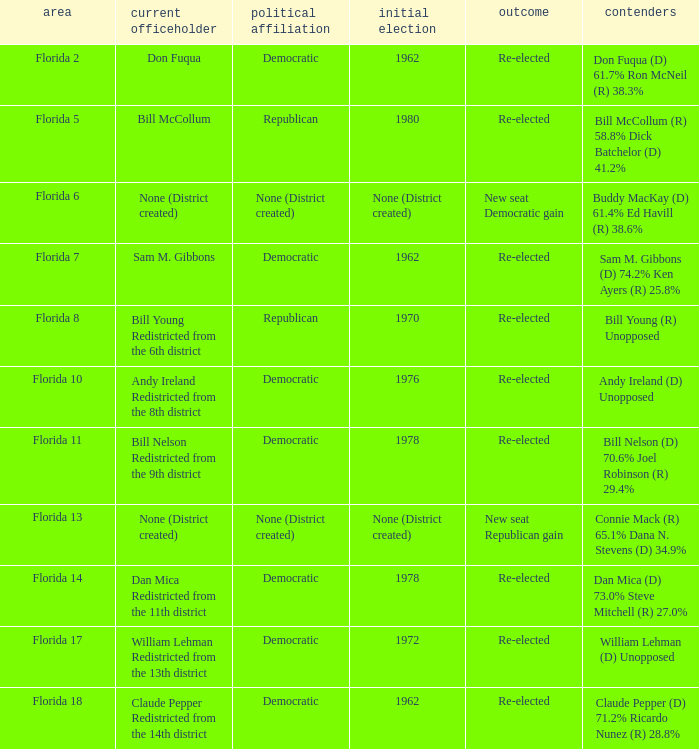Who is the the candidates with incumbent being don fuqua Don Fuqua (D) 61.7% Ron McNeil (R) 38.3%. 